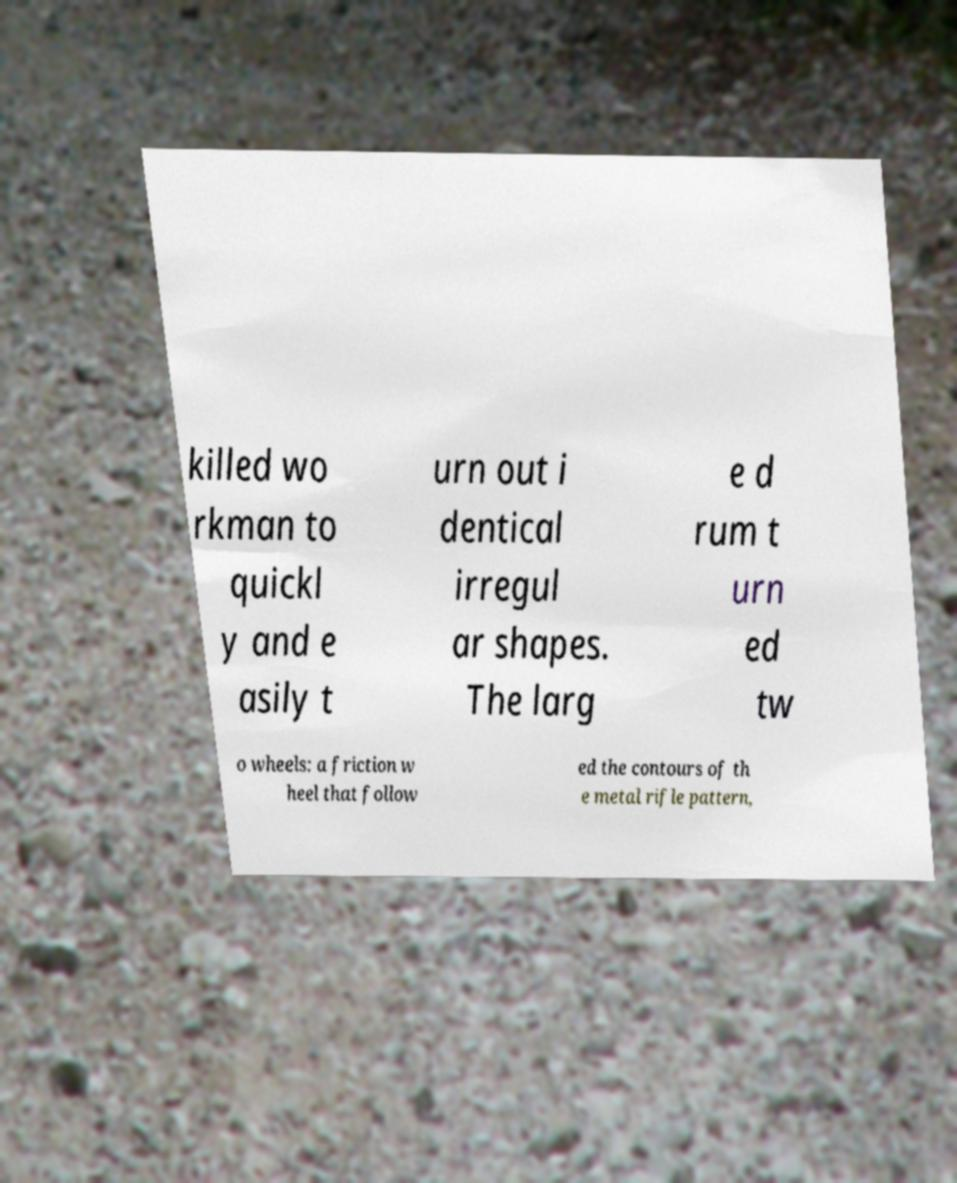I need the written content from this picture converted into text. Can you do that? killed wo rkman to quickl y and e asily t urn out i dentical irregul ar shapes. The larg e d rum t urn ed tw o wheels: a friction w heel that follow ed the contours of th e metal rifle pattern, 